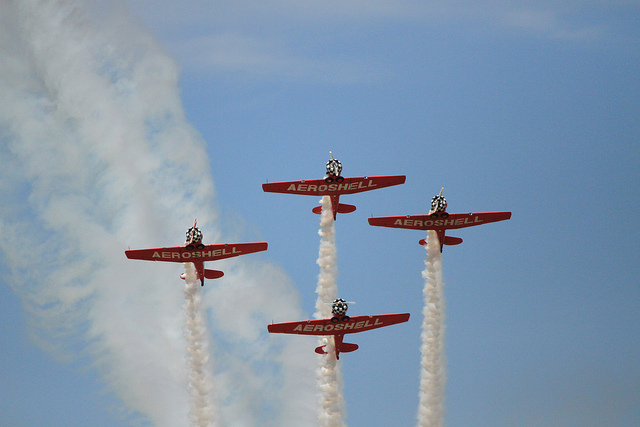<image>Do these planes do tricks? I am not sure if these planes do tricks. Do these planes do tricks? I don't know if these planes do tricks. It is possible that they do. 